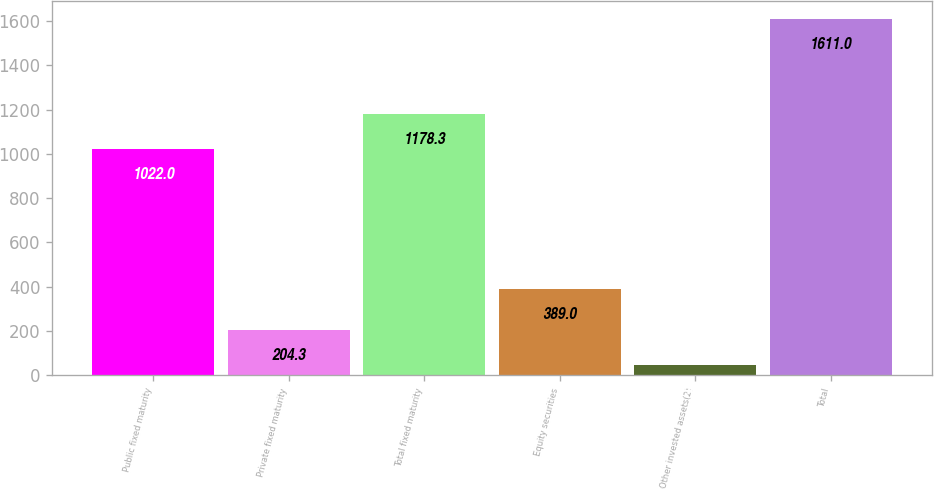Convert chart to OTSL. <chart><loc_0><loc_0><loc_500><loc_500><bar_chart><fcel>Public fixed maturity<fcel>Private fixed maturity<fcel>Total fixed maturity<fcel>Equity securities<fcel>Other invested assets(2)<fcel>Total<nl><fcel>1022<fcel>204.3<fcel>1178.3<fcel>389<fcel>48<fcel>1611<nl></chart> 